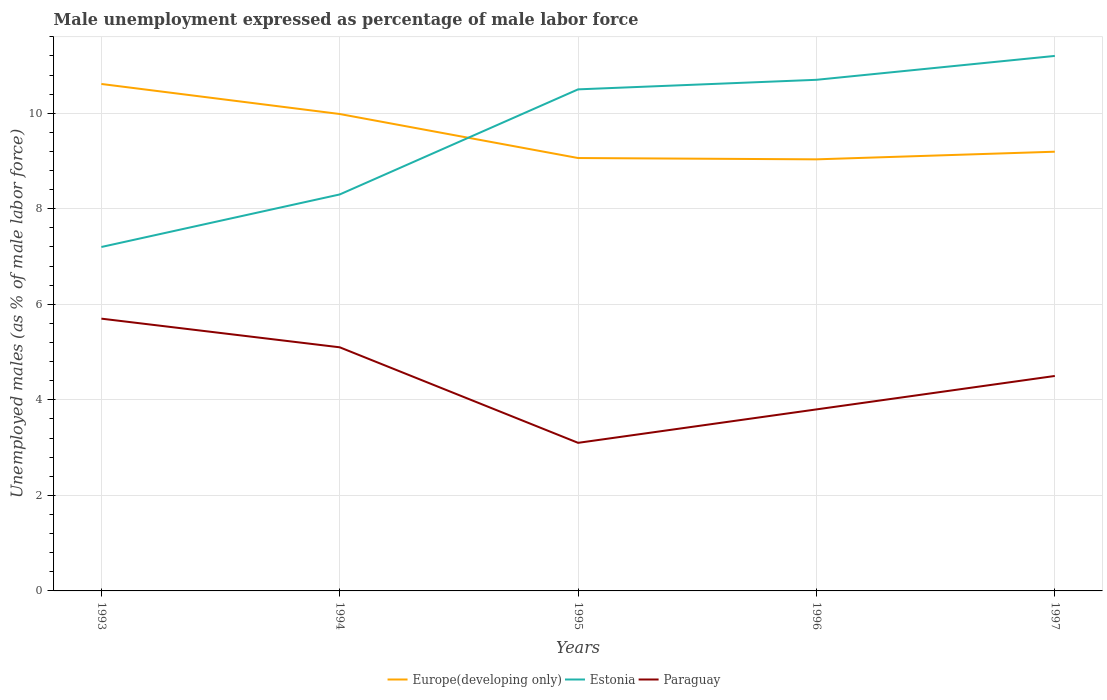Does the line corresponding to Europe(developing only) intersect with the line corresponding to Estonia?
Your response must be concise. Yes. Is the number of lines equal to the number of legend labels?
Give a very brief answer. Yes. Across all years, what is the maximum unemployment in males in in Paraguay?
Ensure brevity in your answer.  3.1. In which year was the unemployment in males in in Paraguay maximum?
Offer a very short reply. 1995. What is the total unemployment in males in in Europe(developing only) in the graph?
Keep it short and to the point. -0.13. What is the difference between the highest and the second highest unemployment in males in in Paraguay?
Your answer should be compact. 2.6. Is the unemployment in males in in Europe(developing only) strictly greater than the unemployment in males in in Paraguay over the years?
Give a very brief answer. No. How many years are there in the graph?
Ensure brevity in your answer.  5. What is the difference between two consecutive major ticks on the Y-axis?
Keep it short and to the point. 2. Does the graph contain grids?
Ensure brevity in your answer.  Yes. How many legend labels are there?
Your answer should be very brief. 3. What is the title of the graph?
Your answer should be very brief. Male unemployment expressed as percentage of male labor force. What is the label or title of the Y-axis?
Your answer should be compact. Unemployed males (as % of male labor force). What is the Unemployed males (as % of male labor force) in Europe(developing only) in 1993?
Offer a very short reply. 10.61. What is the Unemployed males (as % of male labor force) of Estonia in 1993?
Offer a very short reply. 7.2. What is the Unemployed males (as % of male labor force) in Paraguay in 1993?
Give a very brief answer. 5.7. What is the Unemployed males (as % of male labor force) in Europe(developing only) in 1994?
Provide a succinct answer. 9.98. What is the Unemployed males (as % of male labor force) of Estonia in 1994?
Your answer should be compact. 8.3. What is the Unemployed males (as % of male labor force) of Paraguay in 1994?
Provide a short and direct response. 5.1. What is the Unemployed males (as % of male labor force) of Europe(developing only) in 1995?
Make the answer very short. 9.06. What is the Unemployed males (as % of male labor force) of Paraguay in 1995?
Ensure brevity in your answer.  3.1. What is the Unemployed males (as % of male labor force) of Europe(developing only) in 1996?
Provide a short and direct response. 9.03. What is the Unemployed males (as % of male labor force) in Estonia in 1996?
Provide a succinct answer. 10.7. What is the Unemployed males (as % of male labor force) of Paraguay in 1996?
Your answer should be very brief. 3.8. What is the Unemployed males (as % of male labor force) in Europe(developing only) in 1997?
Your answer should be very brief. 9.19. What is the Unemployed males (as % of male labor force) of Estonia in 1997?
Provide a succinct answer. 11.2. Across all years, what is the maximum Unemployed males (as % of male labor force) of Europe(developing only)?
Provide a succinct answer. 10.61. Across all years, what is the maximum Unemployed males (as % of male labor force) of Estonia?
Your answer should be compact. 11.2. Across all years, what is the maximum Unemployed males (as % of male labor force) of Paraguay?
Keep it short and to the point. 5.7. Across all years, what is the minimum Unemployed males (as % of male labor force) of Europe(developing only)?
Keep it short and to the point. 9.03. Across all years, what is the minimum Unemployed males (as % of male labor force) in Estonia?
Your answer should be very brief. 7.2. Across all years, what is the minimum Unemployed males (as % of male labor force) in Paraguay?
Give a very brief answer. 3.1. What is the total Unemployed males (as % of male labor force) in Europe(developing only) in the graph?
Your response must be concise. 47.89. What is the total Unemployed males (as % of male labor force) in Estonia in the graph?
Keep it short and to the point. 47.9. What is the difference between the Unemployed males (as % of male labor force) of Europe(developing only) in 1993 and that in 1994?
Offer a very short reply. 0.63. What is the difference between the Unemployed males (as % of male labor force) in Paraguay in 1993 and that in 1994?
Your response must be concise. 0.6. What is the difference between the Unemployed males (as % of male labor force) of Europe(developing only) in 1993 and that in 1995?
Provide a short and direct response. 1.55. What is the difference between the Unemployed males (as % of male labor force) in Estonia in 1993 and that in 1995?
Make the answer very short. -3.3. What is the difference between the Unemployed males (as % of male labor force) of Paraguay in 1993 and that in 1995?
Make the answer very short. 2.6. What is the difference between the Unemployed males (as % of male labor force) in Europe(developing only) in 1993 and that in 1996?
Give a very brief answer. 1.58. What is the difference between the Unemployed males (as % of male labor force) in Estonia in 1993 and that in 1996?
Keep it short and to the point. -3.5. What is the difference between the Unemployed males (as % of male labor force) of Paraguay in 1993 and that in 1996?
Your answer should be compact. 1.9. What is the difference between the Unemployed males (as % of male labor force) in Europe(developing only) in 1993 and that in 1997?
Provide a succinct answer. 1.42. What is the difference between the Unemployed males (as % of male labor force) of Estonia in 1993 and that in 1997?
Provide a succinct answer. -4. What is the difference between the Unemployed males (as % of male labor force) of Europe(developing only) in 1994 and that in 1995?
Your response must be concise. 0.92. What is the difference between the Unemployed males (as % of male labor force) in Estonia in 1994 and that in 1995?
Offer a terse response. -2.2. What is the difference between the Unemployed males (as % of male labor force) of Paraguay in 1994 and that in 1995?
Your answer should be compact. 2. What is the difference between the Unemployed males (as % of male labor force) of Europe(developing only) in 1994 and that in 1996?
Keep it short and to the point. 0.95. What is the difference between the Unemployed males (as % of male labor force) in Europe(developing only) in 1994 and that in 1997?
Offer a very short reply. 0.79. What is the difference between the Unemployed males (as % of male labor force) of Estonia in 1994 and that in 1997?
Provide a succinct answer. -2.9. What is the difference between the Unemployed males (as % of male labor force) in Europe(developing only) in 1995 and that in 1996?
Provide a succinct answer. 0.03. What is the difference between the Unemployed males (as % of male labor force) in Estonia in 1995 and that in 1996?
Offer a terse response. -0.2. What is the difference between the Unemployed males (as % of male labor force) of Paraguay in 1995 and that in 1996?
Your answer should be compact. -0.7. What is the difference between the Unemployed males (as % of male labor force) of Europe(developing only) in 1995 and that in 1997?
Make the answer very short. -0.13. What is the difference between the Unemployed males (as % of male labor force) of Paraguay in 1995 and that in 1997?
Give a very brief answer. -1.4. What is the difference between the Unemployed males (as % of male labor force) in Europe(developing only) in 1996 and that in 1997?
Ensure brevity in your answer.  -0.16. What is the difference between the Unemployed males (as % of male labor force) in Estonia in 1996 and that in 1997?
Provide a succinct answer. -0.5. What is the difference between the Unemployed males (as % of male labor force) in Paraguay in 1996 and that in 1997?
Provide a succinct answer. -0.7. What is the difference between the Unemployed males (as % of male labor force) of Europe(developing only) in 1993 and the Unemployed males (as % of male labor force) of Estonia in 1994?
Keep it short and to the point. 2.31. What is the difference between the Unemployed males (as % of male labor force) of Europe(developing only) in 1993 and the Unemployed males (as % of male labor force) of Paraguay in 1994?
Provide a succinct answer. 5.51. What is the difference between the Unemployed males (as % of male labor force) of Europe(developing only) in 1993 and the Unemployed males (as % of male labor force) of Estonia in 1995?
Your response must be concise. 0.11. What is the difference between the Unemployed males (as % of male labor force) of Europe(developing only) in 1993 and the Unemployed males (as % of male labor force) of Paraguay in 1995?
Give a very brief answer. 7.51. What is the difference between the Unemployed males (as % of male labor force) of Europe(developing only) in 1993 and the Unemployed males (as % of male labor force) of Estonia in 1996?
Your answer should be compact. -0.09. What is the difference between the Unemployed males (as % of male labor force) of Europe(developing only) in 1993 and the Unemployed males (as % of male labor force) of Paraguay in 1996?
Provide a succinct answer. 6.81. What is the difference between the Unemployed males (as % of male labor force) in Estonia in 1993 and the Unemployed males (as % of male labor force) in Paraguay in 1996?
Ensure brevity in your answer.  3.4. What is the difference between the Unemployed males (as % of male labor force) in Europe(developing only) in 1993 and the Unemployed males (as % of male labor force) in Estonia in 1997?
Your response must be concise. -0.59. What is the difference between the Unemployed males (as % of male labor force) in Europe(developing only) in 1993 and the Unemployed males (as % of male labor force) in Paraguay in 1997?
Your answer should be compact. 6.11. What is the difference between the Unemployed males (as % of male labor force) of Europe(developing only) in 1994 and the Unemployed males (as % of male labor force) of Estonia in 1995?
Offer a very short reply. -0.52. What is the difference between the Unemployed males (as % of male labor force) of Europe(developing only) in 1994 and the Unemployed males (as % of male labor force) of Paraguay in 1995?
Make the answer very short. 6.88. What is the difference between the Unemployed males (as % of male labor force) of Estonia in 1994 and the Unemployed males (as % of male labor force) of Paraguay in 1995?
Your response must be concise. 5.2. What is the difference between the Unemployed males (as % of male labor force) of Europe(developing only) in 1994 and the Unemployed males (as % of male labor force) of Estonia in 1996?
Make the answer very short. -0.72. What is the difference between the Unemployed males (as % of male labor force) in Europe(developing only) in 1994 and the Unemployed males (as % of male labor force) in Paraguay in 1996?
Provide a succinct answer. 6.18. What is the difference between the Unemployed males (as % of male labor force) of Europe(developing only) in 1994 and the Unemployed males (as % of male labor force) of Estonia in 1997?
Your response must be concise. -1.22. What is the difference between the Unemployed males (as % of male labor force) in Europe(developing only) in 1994 and the Unemployed males (as % of male labor force) in Paraguay in 1997?
Ensure brevity in your answer.  5.48. What is the difference between the Unemployed males (as % of male labor force) in Europe(developing only) in 1995 and the Unemployed males (as % of male labor force) in Estonia in 1996?
Your answer should be very brief. -1.64. What is the difference between the Unemployed males (as % of male labor force) of Europe(developing only) in 1995 and the Unemployed males (as % of male labor force) of Paraguay in 1996?
Your answer should be very brief. 5.26. What is the difference between the Unemployed males (as % of male labor force) of Estonia in 1995 and the Unemployed males (as % of male labor force) of Paraguay in 1996?
Provide a succinct answer. 6.7. What is the difference between the Unemployed males (as % of male labor force) of Europe(developing only) in 1995 and the Unemployed males (as % of male labor force) of Estonia in 1997?
Offer a very short reply. -2.14. What is the difference between the Unemployed males (as % of male labor force) in Europe(developing only) in 1995 and the Unemployed males (as % of male labor force) in Paraguay in 1997?
Provide a succinct answer. 4.56. What is the difference between the Unemployed males (as % of male labor force) of Estonia in 1995 and the Unemployed males (as % of male labor force) of Paraguay in 1997?
Offer a terse response. 6. What is the difference between the Unemployed males (as % of male labor force) in Europe(developing only) in 1996 and the Unemployed males (as % of male labor force) in Estonia in 1997?
Offer a very short reply. -2.17. What is the difference between the Unemployed males (as % of male labor force) of Europe(developing only) in 1996 and the Unemployed males (as % of male labor force) of Paraguay in 1997?
Offer a very short reply. 4.53. What is the average Unemployed males (as % of male labor force) of Europe(developing only) per year?
Make the answer very short. 9.58. What is the average Unemployed males (as % of male labor force) in Estonia per year?
Make the answer very short. 9.58. What is the average Unemployed males (as % of male labor force) of Paraguay per year?
Your response must be concise. 4.44. In the year 1993, what is the difference between the Unemployed males (as % of male labor force) of Europe(developing only) and Unemployed males (as % of male labor force) of Estonia?
Make the answer very short. 3.41. In the year 1993, what is the difference between the Unemployed males (as % of male labor force) in Europe(developing only) and Unemployed males (as % of male labor force) in Paraguay?
Provide a succinct answer. 4.91. In the year 1993, what is the difference between the Unemployed males (as % of male labor force) of Estonia and Unemployed males (as % of male labor force) of Paraguay?
Your answer should be compact. 1.5. In the year 1994, what is the difference between the Unemployed males (as % of male labor force) of Europe(developing only) and Unemployed males (as % of male labor force) of Estonia?
Provide a short and direct response. 1.68. In the year 1994, what is the difference between the Unemployed males (as % of male labor force) in Europe(developing only) and Unemployed males (as % of male labor force) in Paraguay?
Give a very brief answer. 4.88. In the year 1994, what is the difference between the Unemployed males (as % of male labor force) of Estonia and Unemployed males (as % of male labor force) of Paraguay?
Ensure brevity in your answer.  3.2. In the year 1995, what is the difference between the Unemployed males (as % of male labor force) in Europe(developing only) and Unemployed males (as % of male labor force) in Estonia?
Offer a very short reply. -1.44. In the year 1995, what is the difference between the Unemployed males (as % of male labor force) of Europe(developing only) and Unemployed males (as % of male labor force) of Paraguay?
Keep it short and to the point. 5.96. In the year 1995, what is the difference between the Unemployed males (as % of male labor force) in Estonia and Unemployed males (as % of male labor force) in Paraguay?
Provide a short and direct response. 7.4. In the year 1996, what is the difference between the Unemployed males (as % of male labor force) of Europe(developing only) and Unemployed males (as % of male labor force) of Estonia?
Your response must be concise. -1.67. In the year 1996, what is the difference between the Unemployed males (as % of male labor force) in Europe(developing only) and Unemployed males (as % of male labor force) in Paraguay?
Keep it short and to the point. 5.23. In the year 1996, what is the difference between the Unemployed males (as % of male labor force) in Estonia and Unemployed males (as % of male labor force) in Paraguay?
Your answer should be compact. 6.9. In the year 1997, what is the difference between the Unemployed males (as % of male labor force) in Europe(developing only) and Unemployed males (as % of male labor force) in Estonia?
Your answer should be very brief. -2. In the year 1997, what is the difference between the Unemployed males (as % of male labor force) in Europe(developing only) and Unemployed males (as % of male labor force) in Paraguay?
Provide a short and direct response. 4.7. In the year 1997, what is the difference between the Unemployed males (as % of male labor force) in Estonia and Unemployed males (as % of male labor force) in Paraguay?
Keep it short and to the point. 6.7. What is the ratio of the Unemployed males (as % of male labor force) in Europe(developing only) in 1993 to that in 1994?
Your response must be concise. 1.06. What is the ratio of the Unemployed males (as % of male labor force) in Estonia in 1993 to that in 1994?
Make the answer very short. 0.87. What is the ratio of the Unemployed males (as % of male labor force) in Paraguay in 1993 to that in 1994?
Give a very brief answer. 1.12. What is the ratio of the Unemployed males (as % of male labor force) in Europe(developing only) in 1993 to that in 1995?
Your answer should be very brief. 1.17. What is the ratio of the Unemployed males (as % of male labor force) in Estonia in 1993 to that in 1995?
Your answer should be very brief. 0.69. What is the ratio of the Unemployed males (as % of male labor force) of Paraguay in 1993 to that in 1995?
Your answer should be very brief. 1.84. What is the ratio of the Unemployed males (as % of male labor force) of Europe(developing only) in 1993 to that in 1996?
Provide a succinct answer. 1.17. What is the ratio of the Unemployed males (as % of male labor force) in Estonia in 1993 to that in 1996?
Provide a succinct answer. 0.67. What is the ratio of the Unemployed males (as % of male labor force) of Paraguay in 1993 to that in 1996?
Give a very brief answer. 1.5. What is the ratio of the Unemployed males (as % of male labor force) of Europe(developing only) in 1993 to that in 1997?
Ensure brevity in your answer.  1.15. What is the ratio of the Unemployed males (as % of male labor force) in Estonia in 1993 to that in 1997?
Provide a succinct answer. 0.64. What is the ratio of the Unemployed males (as % of male labor force) of Paraguay in 1993 to that in 1997?
Offer a terse response. 1.27. What is the ratio of the Unemployed males (as % of male labor force) in Europe(developing only) in 1994 to that in 1995?
Ensure brevity in your answer.  1.1. What is the ratio of the Unemployed males (as % of male labor force) in Estonia in 1994 to that in 1995?
Keep it short and to the point. 0.79. What is the ratio of the Unemployed males (as % of male labor force) of Paraguay in 1994 to that in 1995?
Make the answer very short. 1.65. What is the ratio of the Unemployed males (as % of male labor force) of Europe(developing only) in 1994 to that in 1996?
Your answer should be very brief. 1.11. What is the ratio of the Unemployed males (as % of male labor force) in Estonia in 1994 to that in 1996?
Keep it short and to the point. 0.78. What is the ratio of the Unemployed males (as % of male labor force) in Paraguay in 1994 to that in 1996?
Ensure brevity in your answer.  1.34. What is the ratio of the Unemployed males (as % of male labor force) in Europe(developing only) in 1994 to that in 1997?
Ensure brevity in your answer.  1.09. What is the ratio of the Unemployed males (as % of male labor force) in Estonia in 1994 to that in 1997?
Give a very brief answer. 0.74. What is the ratio of the Unemployed males (as % of male labor force) in Paraguay in 1994 to that in 1997?
Make the answer very short. 1.13. What is the ratio of the Unemployed males (as % of male labor force) of Europe(developing only) in 1995 to that in 1996?
Your answer should be very brief. 1. What is the ratio of the Unemployed males (as % of male labor force) in Estonia in 1995 to that in 1996?
Ensure brevity in your answer.  0.98. What is the ratio of the Unemployed males (as % of male labor force) of Paraguay in 1995 to that in 1996?
Provide a succinct answer. 0.82. What is the ratio of the Unemployed males (as % of male labor force) in Europe(developing only) in 1995 to that in 1997?
Provide a short and direct response. 0.99. What is the ratio of the Unemployed males (as % of male labor force) of Estonia in 1995 to that in 1997?
Make the answer very short. 0.94. What is the ratio of the Unemployed males (as % of male labor force) of Paraguay in 1995 to that in 1997?
Ensure brevity in your answer.  0.69. What is the ratio of the Unemployed males (as % of male labor force) of Europe(developing only) in 1996 to that in 1997?
Your answer should be compact. 0.98. What is the ratio of the Unemployed males (as % of male labor force) of Estonia in 1996 to that in 1997?
Your answer should be very brief. 0.96. What is the ratio of the Unemployed males (as % of male labor force) of Paraguay in 1996 to that in 1997?
Offer a terse response. 0.84. What is the difference between the highest and the second highest Unemployed males (as % of male labor force) of Europe(developing only)?
Offer a very short reply. 0.63. What is the difference between the highest and the second highest Unemployed males (as % of male labor force) of Estonia?
Make the answer very short. 0.5. What is the difference between the highest and the second highest Unemployed males (as % of male labor force) of Paraguay?
Provide a short and direct response. 0.6. What is the difference between the highest and the lowest Unemployed males (as % of male labor force) of Europe(developing only)?
Ensure brevity in your answer.  1.58. 